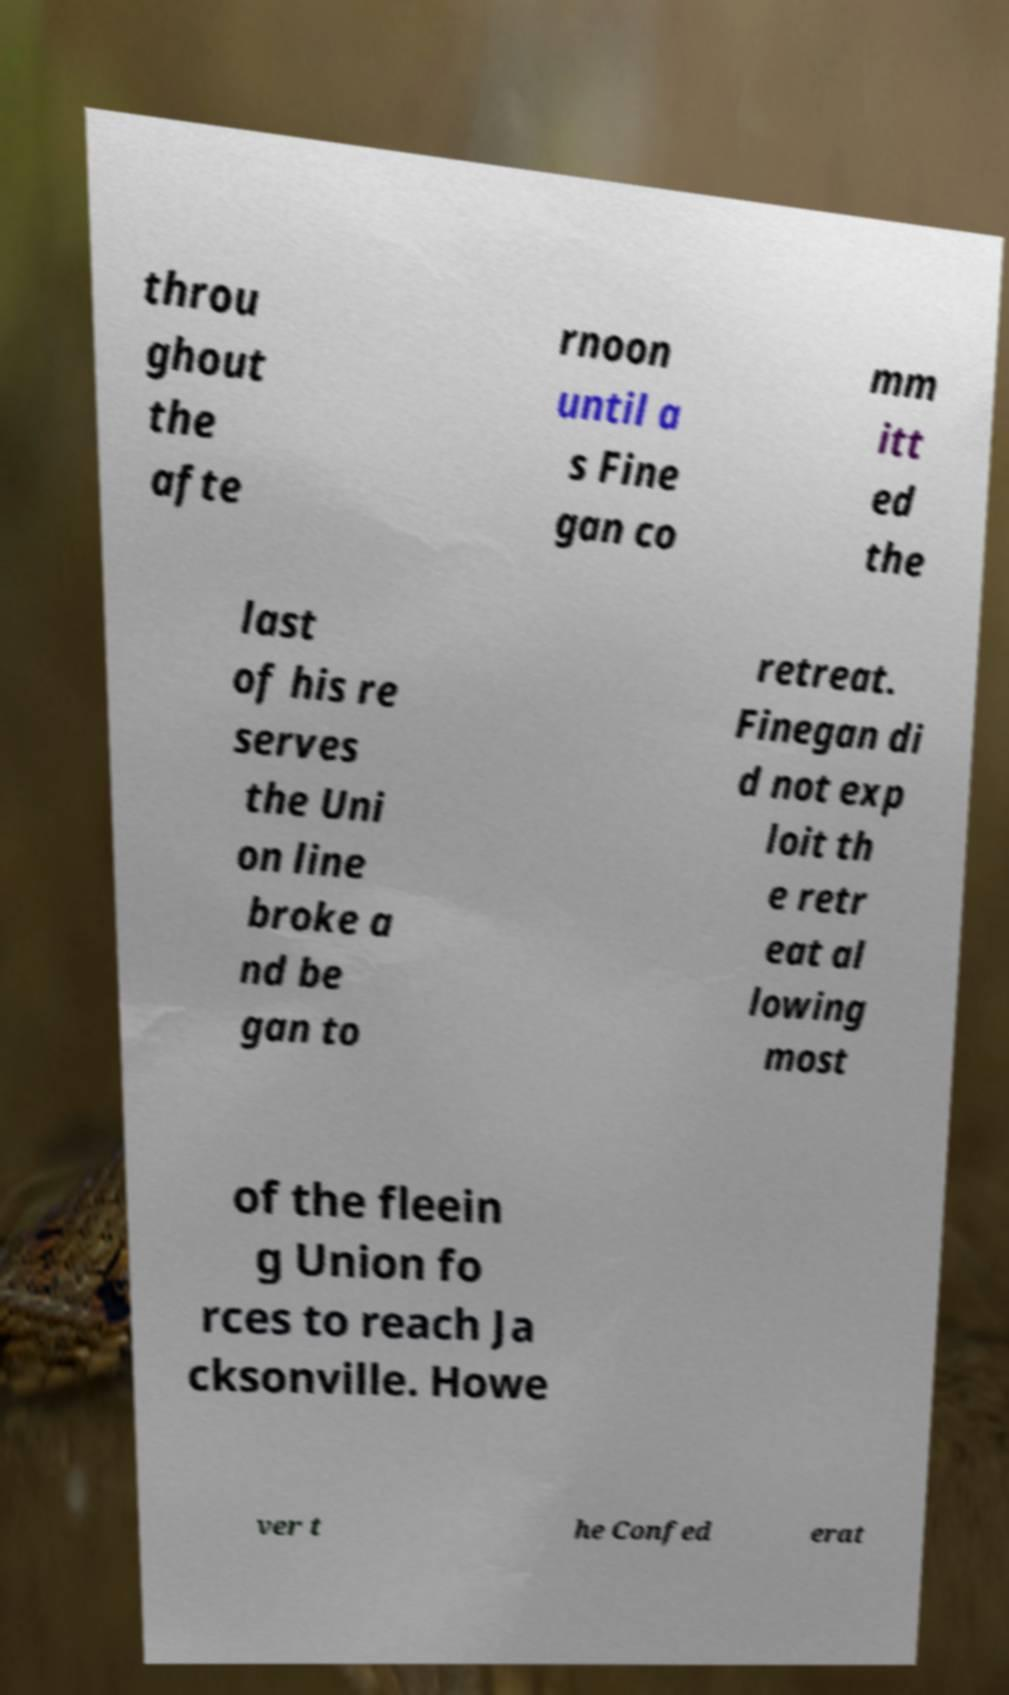Please identify and transcribe the text found in this image. throu ghout the afte rnoon until a s Fine gan co mm itt ed the last of his re serves the Uni on line broke a nd be gan to retreat. Finegan di d not exp loit th e retr eat al lowing most of the fleein g Union fo rces to reach Ja cksonville. Howe ver t he Confed erat 